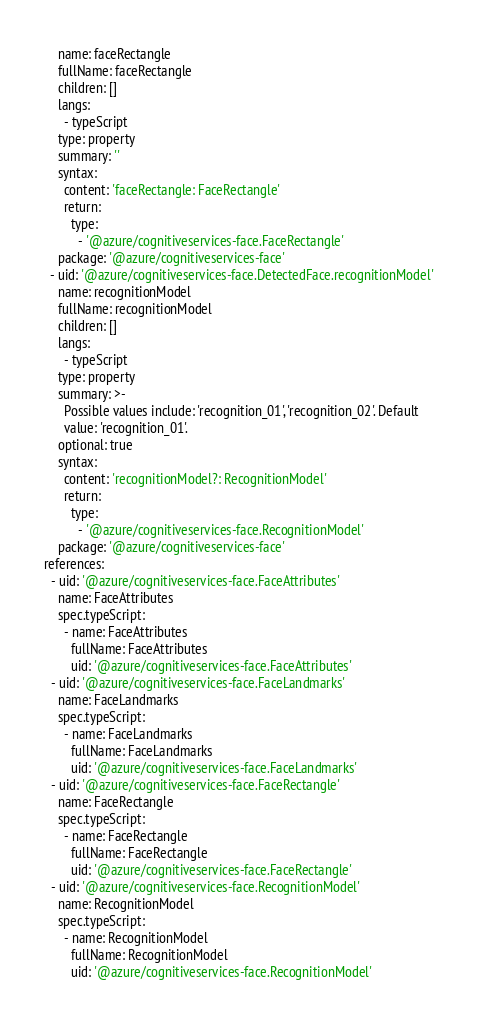Convert code to text. <code><loc_0><loc_0><loc_500><loc_500><_YAML_>    name: faceRectangle
    fullName: faceRectangle
    children: []
    langs:
      - typeScript
    type: property
    summary: ''
    syntax:
      content: 'faceRectangle: FaceRectangle'
      return:
        type:
          - '@azure/cognitiveservices-face.FaceRectangle'
    package: '@azure/cognitiveservices-face'
  - uid: '@azure/cognitiveservices-face.DetectedFace.recognitionModel'
    name: recognitionModel
    fullName: recognitionModel
    children: []
    langs:
      - typeScript
    type: property
    summary: >-
      Possible values include: 'recognition_01', 'recognition_02'. Default
      value: 'recognition_01'.
    optional: true
    syntax:
      content: 'recognitionModel?: RecognitionModel'
      return:
        type:
          - '@azure/cognitiveservices-face.RecognitionModel'
    package: '@azure/cognitiveservices-face'
references:
  - uid: '@azure/cognitiveservices-face.FaceAttributes'
    name: FaceAttributes
    spec.typeScript:
      - name: FaceAttributes
        fullName: FaceAttributes
        uid: '@azure/cognitiveservices-face.FaceAttributes'
  - uid: '@azure/cognitiveservices-face.FaceLandmarks'
    name: FaceLandmarks
    spec.typeScript:
      - name: FaceLandmarks
        fullName: FaceLandmarks
        uid: '@azure/cognitiveservices-face.FaceLandmarks'
  - uid: '@azure/cognitiveservices-face.FaceRectangle'
    name: FaceRectangle
    spec.typeScript:
      - name: FaceRectangle
        fullName: FaceRectangle
        uid: '@azure/cognitiveservices-face.FaceRectangle'
  - uid: '@azure/cognitiveservices-face.RecognitionModel'
    name: RecognitionModel
    spec.typeScript:
      - name: RecognitionModel
        fullName: RecognitionModel
        uid: '@azure/cognitiveservices-face.RecognitionModel'
</code> 